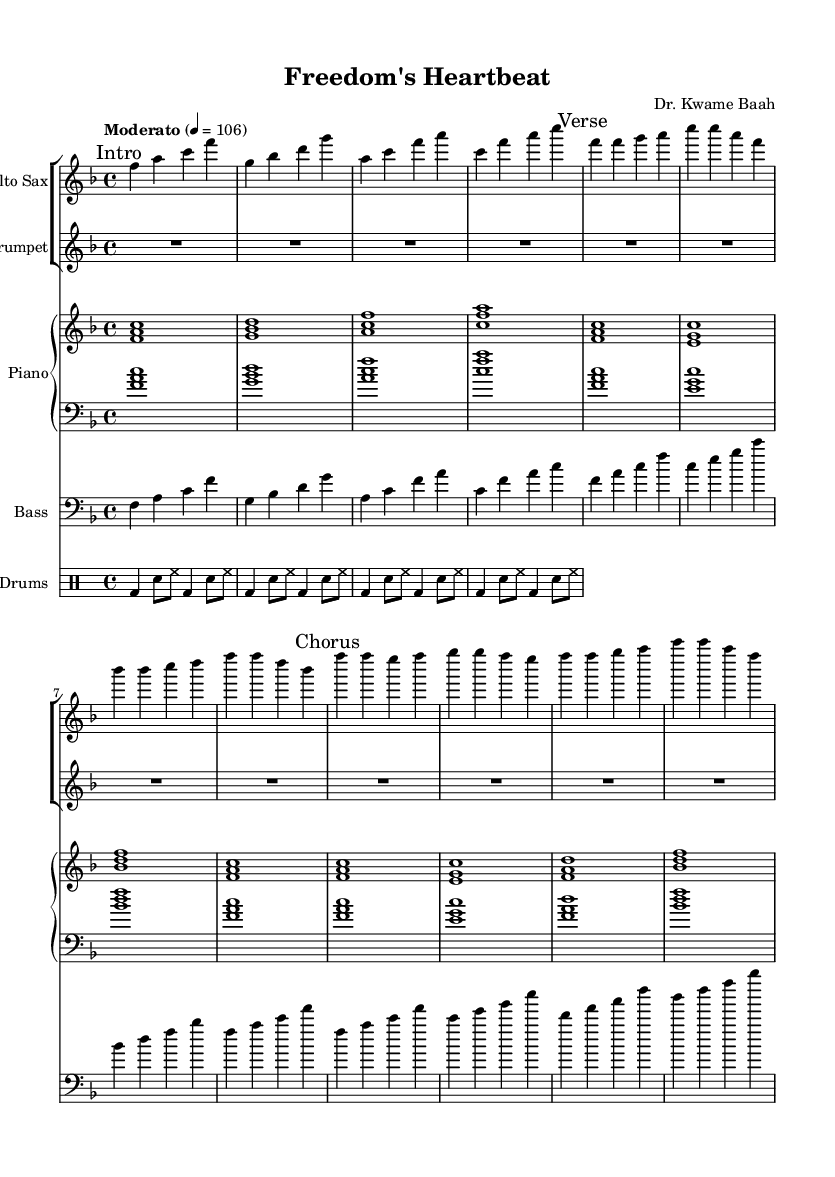What is the key signature of this music? The key signature is F major, which has one flat (B flat). This can be derived from the music sheet which indicates \key f \major at the beginning.
Answer: F major What is the time signature used in this piece? The time signature is 4/4, which is indicated at the beginning of the score with \time 4/4. This means there are four beats per measure.
Answer: 4/4 What is the tempo marking for this piece? The tempo marking is "Moderato" at a speed of 106 beats per minute, as indicated by \tempo "Moderato" 4 = 106 in the global settings.
Answer: Moderato, 106 What instrument has no notes written in its part? The instrument with no notes is the trumpet; its part has only rests (notated as R1*4) and no pitches. This shows it is resting for the duration of the measure.
Answer: Trumpet What musical section introduces the main theme? The main theme is introduced in the "Chorus" section, where distinct melodies are presented. The section is clearly marked and contrasts with the preceding "Verse."
Answer: Chorus How many measures are present in the "Verse" section? The "Verse" section consists of four measures, which can be counted from the notation where each distinct part is separated by vertical lines (bars). The notes in this section appear in a continuous flow to signify four complete measures.
Answer: 4 What style of fusion does this music represent? This music represents Afro-jazz fusion, as it combines traditional African musical elements with jazz influences, reflecting Ghana's culture and history. The interplay of instruments and rhythms signifies this fusion.
Answer: Afro-jazz 